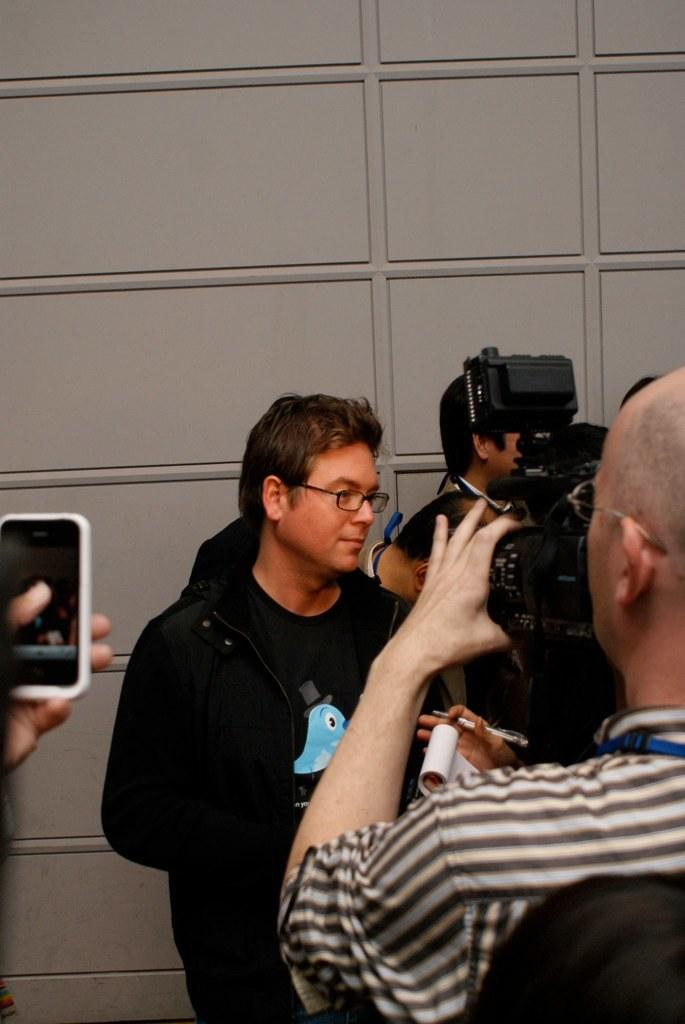What is the main subject of the image? There is a person in the image. What is the person wearing? The person is wearing a black color shirt. Can you describe the other person in the image? There is another person at the right side of the image. What is the second person doing? The person at the right side is taking a photograph of the person wearing the black color shirt. What type of truck can be seen in the image? There is no truck present in the image. Is the sun visible in the image? The provided facts do not mention the sun, so we cannot determine if it is visible in the image. --- Facts: 1. There is a car in the image. 2. The car is parked on the street. 3. There are trees in the background of the image. 4. The sky is visible in the image. 5. The car has a red color. Absurd Topics: bird, rain, bicycle Conversation: What is the main subject of the image? There is a car in the image. Where is the car located? The car is parked on the street. What can be seen in the background of the image? There are trees in the background of the image. What is visible at the top of the image? The sky is visible in the image. What is the color of the car? The car has a red color. Reasoning: Let's think step by step in order to produce the conversation. We start by identifying the main subject of the image, which is the car. Then, we describe the car's location, which is parked on the street. Next, we mention the presence of trees and the sky in the background and at the top of the image, respectively. Finally, we provide the color of the car, which is red. Each question is designed to elicit a specific detail about the image that is known from the provided facts. Absurd Question/Answer: Can you see a bird flying in the image? There is no mention of a bird in the image, so we cannot determine if one is present. Is it raining in the image? The provided facts do not mention rain, so we cannot determine if it is raining in the image. 